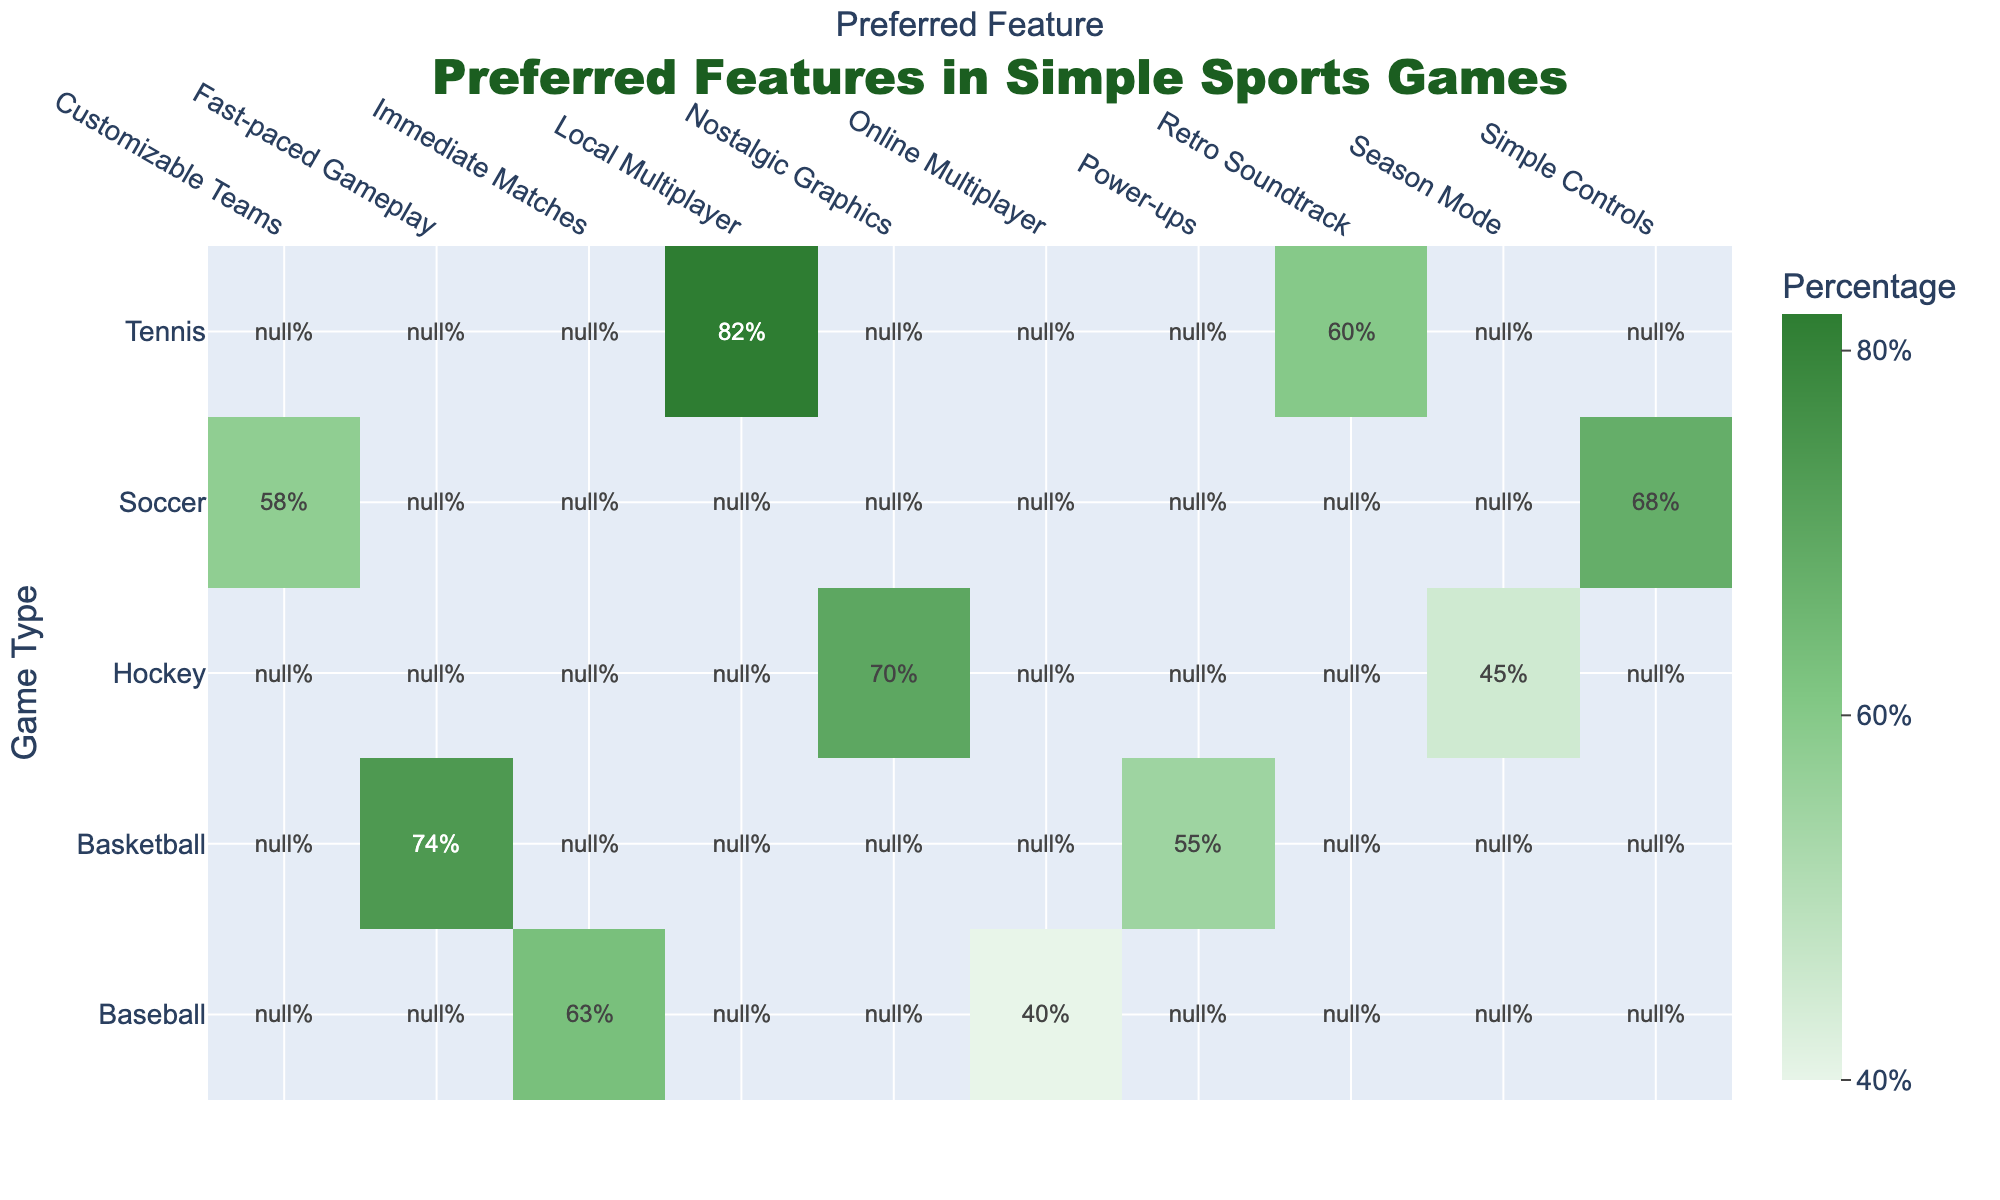What is the preferred feature with the highest percentage for Tennis? From the table, we can see that for Tennis, the highest percentage associated with a preferred feature is 82% for Local Multiplayer.
Answer: Local Multiplayer Is the percentage of players who prefer Simple Controls in Soccer higher than the percentage for Immediate Matches in Baseball? According to the table, Simple Controls in Soccer has a percentage of 68%, while Immediate Matches in Baseball has 63%. Since 68% is greater than 63%, the answer is yes.
Answer: Yes What is the average percentage for the preferred features in Baseball? The percentages for the preferred features in Baseball are 63% for Immediate Matches and 40% for Online Multiplayer. To find the average: (63 + 40) / 2 = 103 / 2 = 51.5.
Answer: 51.5 Which game type has the lowest percentage for a preferred feature? Looking at the table, Hockey has the lowest percentage for Season Mode with 45%. This can be determined by comparing all the percentages listed for each game type.
Answer: Season Mode, 45% If we combine the percentages for Fast-paced Gameplay and Power-ups in Basketball, what would that result in? The percentage for Fast-paced Gameplay in Basketball is 74%, and Power-ups is 55%. Adding these two percentages together gives us 74 + 55 = 129.
Answer: 129 Are Nostalgic Graphics preferred more than Customizable Teams in Soccer? Nostalgic Graphics has a percentage of 70%, while Customizable Teams has a percentage of 58%. Since 70% is greater than 58%, the answer is yes.
Answer: Yes What is the difference between the highest and lowest percentages from the table? To find the highest percentage, we look through the table and find Local Multiplayer in Tennis at 82% as the highest. The lowest is Online Multiplayer in Baseball at 40%. The difference is 82 - 40 = 42.
Answer: 42 In which game type do players show the least interest in Online Multiplayer? According to the table, the percentage for Online Multiplayer is 40% in Baseball, which is the only game type listed for this feature. Thus, it's also the lowest.
Answer: Baseball, 40% What preferred feature do the majority of players (more than 50%) favor in Tennis? The percentages for preferred features in Tennis are 82% for Local Multiplayer and 60% for Retro Soundtrack. Both are greater than 50%, indicating that the majority of players favor both features.
Answer: Local Multiplayer, 82% and Retro Soundtrack, 60% 